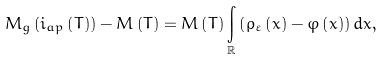Convert formula to latex. <formula><loc_0><loc_0><loc_500><loc_500>M _ { g } \left ( i _ { a p } \left ( T \right ) \right ) - M \left ( T \right ) = M \left ( T \right ) \underset { \mathbb { R } } { \int } \left ( \rho _ { \varepsilon } \left ( x \right ) - \varphi \left ( x \right ) \right ) d x ,</formula> 